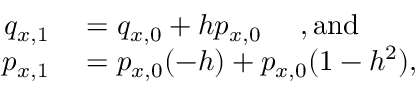<formula> <loc_0><loc_0><loc_500><loc_500>\begin{array} { r l } { q _ { x , 1 } } & = q _ { x , 0 } + h p _ { x , 0 } , a n d } \\ { p _ { x , 1 } } & = p _ { x , 0 } ( - h ) + p _ { x , 0 } ( 1 - h ^ { 2 } ) , } \end{array}</formula> 